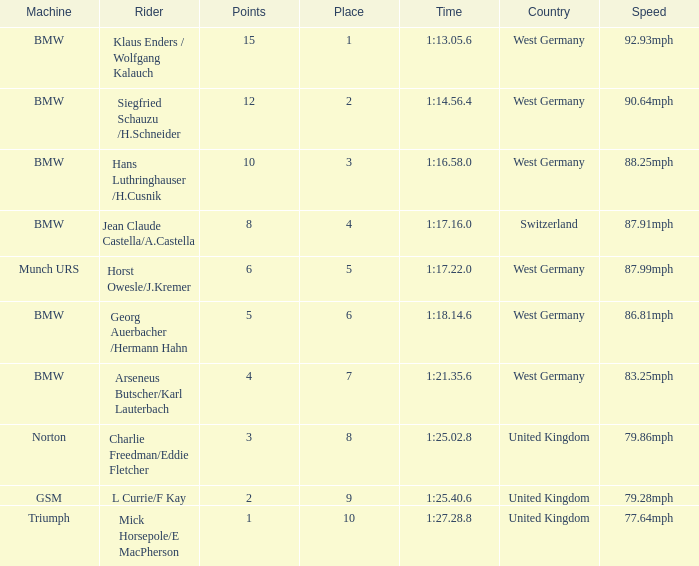Which places have points larger than 10? None. 